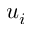Convert formula to latex. <formula><loc_0><loc_0><loc_500><loc_500>u _ { i }</formula> 